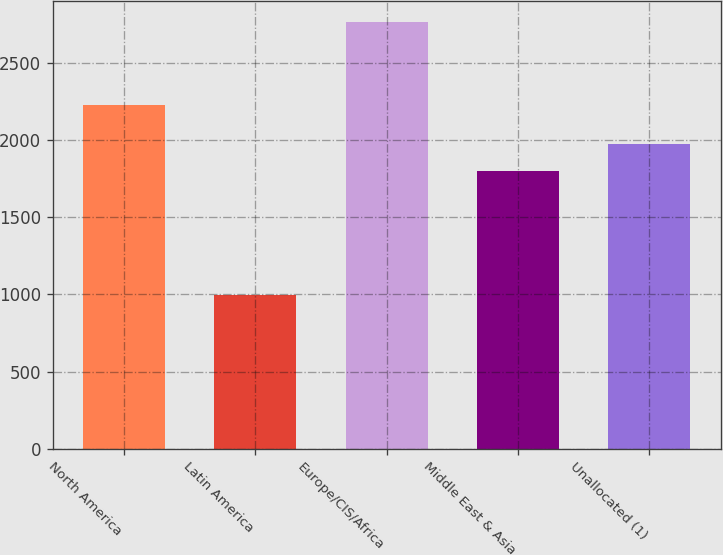Convert chart. <chart><loc_0><loc_0><loc_500><loc_500><bar_chart><fcel>North America<fcel>Latin America<fcel>Europe/CIS/Africa<fcel>Middle East & Asia<fcel>Unallocated (1)<nl><fcel>2229<fcel>995<fcel>2763<fcel>1797<fcel>1973.8<nl></chart> 